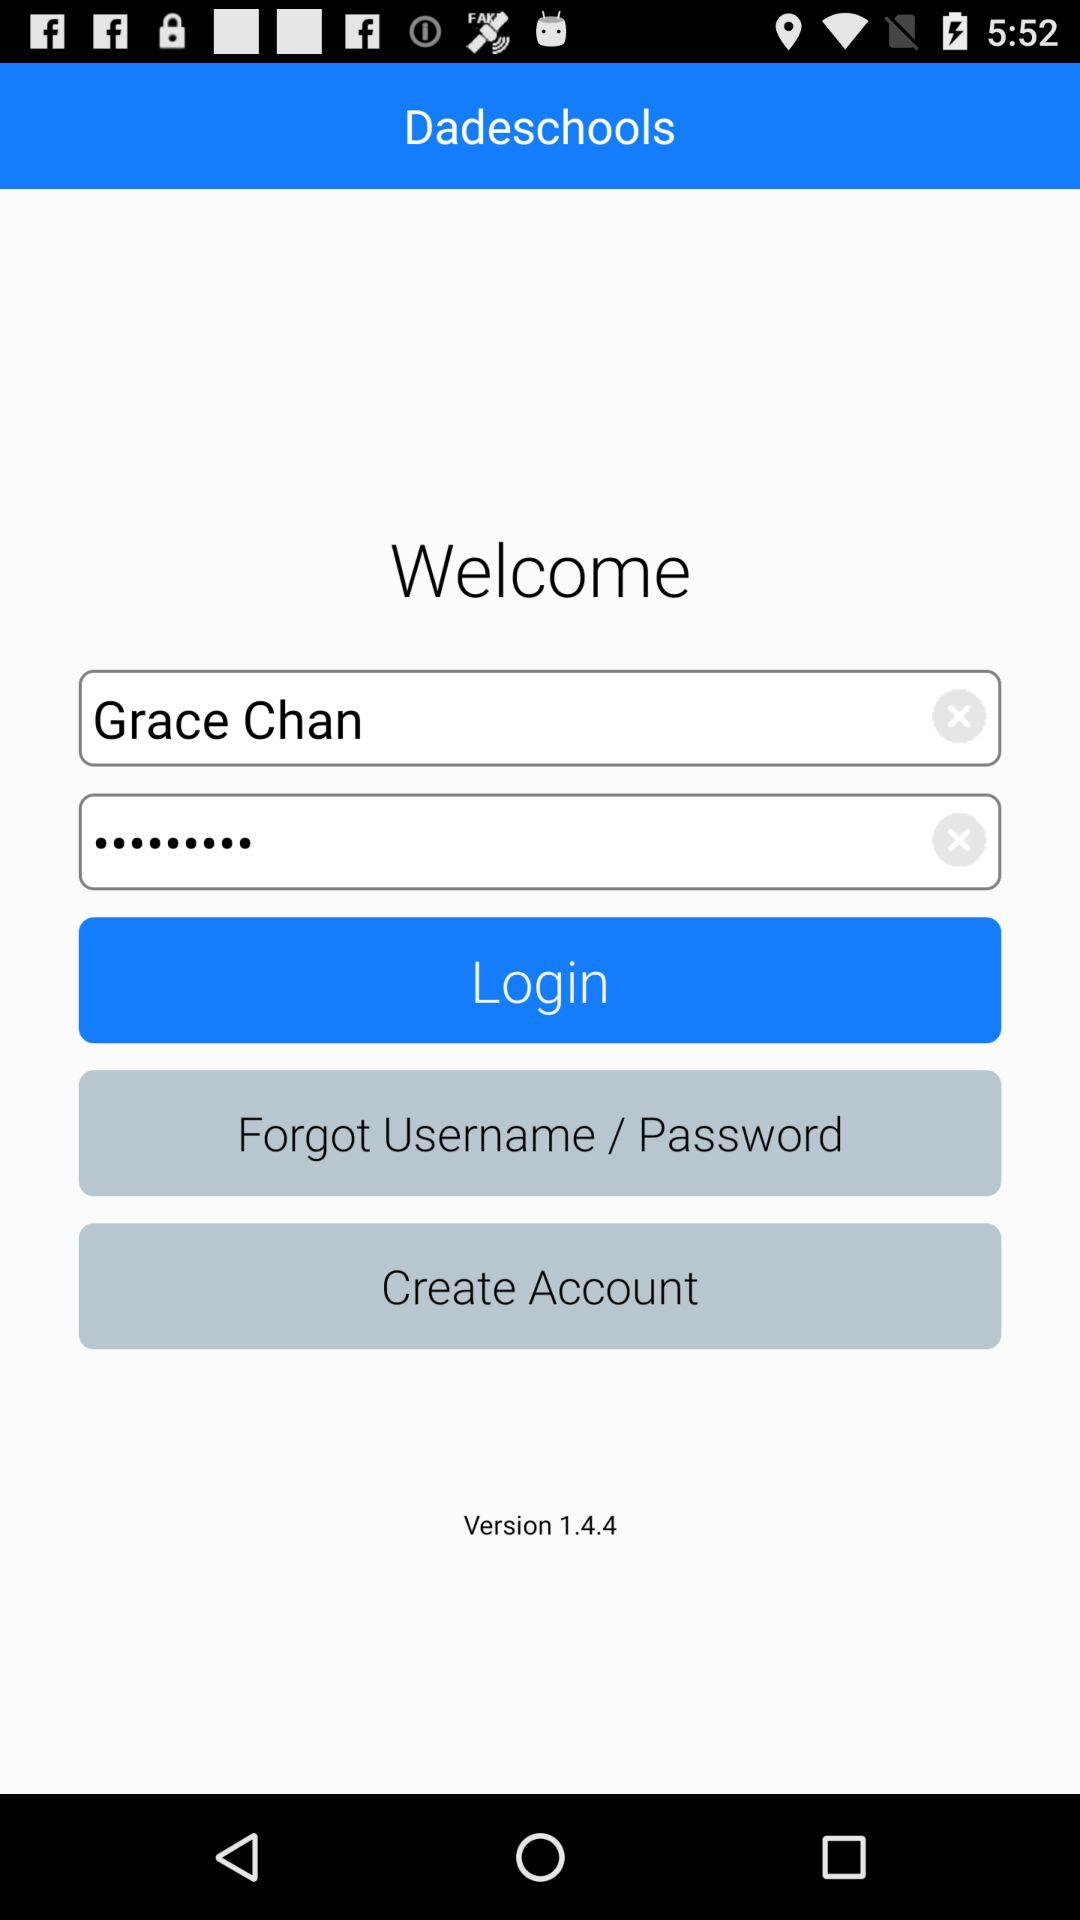What is the user name? The user name is Grace Chan. 